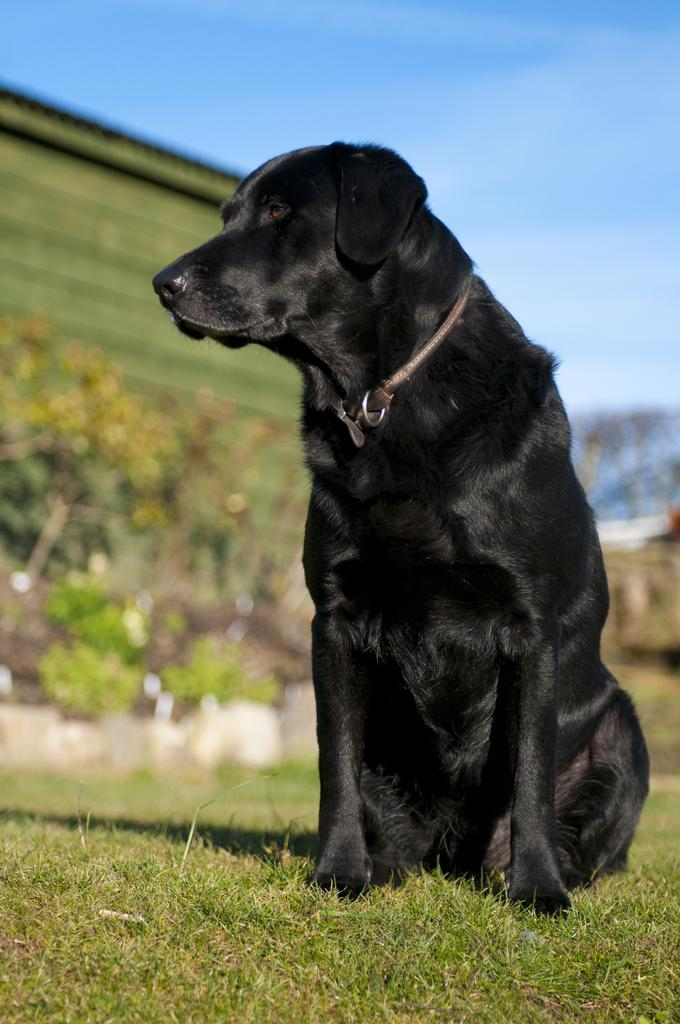What is the main subject in the center of the image? There is a dog in the center of the image. What is the dog standing on? The dog is on the grass. What can be seen in the background of the image? There is a building, trees, plants, and the sky visible in the background of the image. How many mittens is the dog wearing in the image? There are no mittens present in the image; the dog is not wearing any clothing. 